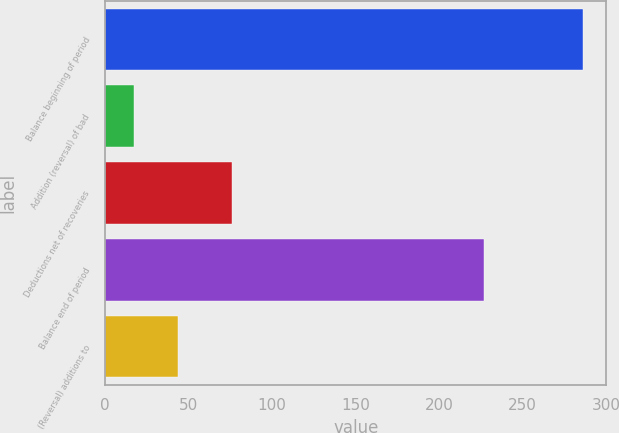Convert chart to OTSL. <chart><loc_0><loc_0><loc_500><loc_500><bar_chart><fcel>Balance beginning of period<fcel>Addition (reversal) of bad<fcel>Deductions net of recoveries<fcel>Balance end of period<fcel>(Reversal) additions to<nl><fcel>286<fcel>17<fcel>76<fcel>227<fcel>43.9<nl></chart> 